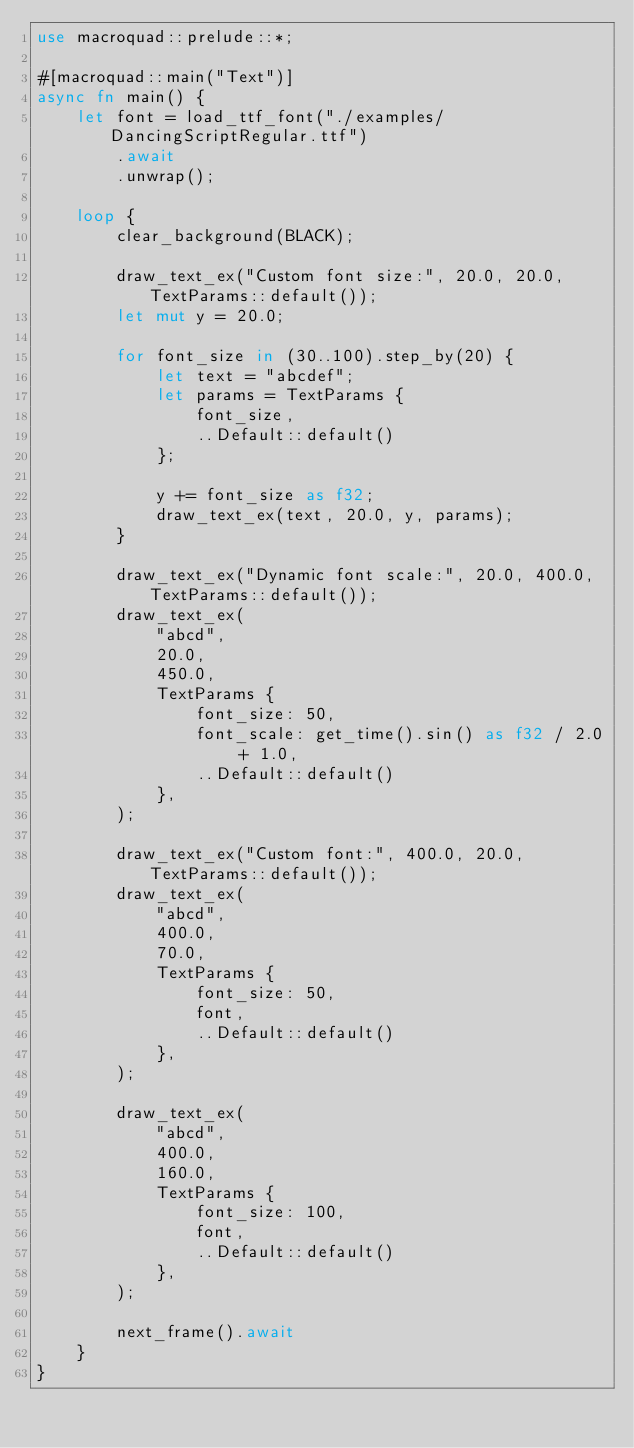<code> <loc_0><loc_0><loc_500><loc_500><_Rust_>use macroquad::prelude::*;

#[macroquad::main("Text")]
async fn main() {
    let font = load_ttf_font("./examples/DancingScriptRegular.ttf")
        .await
        .unwrap();

    loop {
        clear_background(BLACK);

        draw_text_ex("Custom font size:", 20.0, 20.0, TextParams::default());
        let mut y = 20.0;

        for font_size in (30..100).step_by(20) {
            let text = "abcdef";
            let params = TextParams {
                font_size,
                ..Default::default()
            };

            y += font_size as f32;
            draw_text_ex(text, 20.0, y, params);
        }

        draw_text_ex("Dynamic font scale:", 20.0, 400.0, TextParams::default());
        draw_text_ex(
            "abcd",
            20.0,
            450.0,
            TextParams {
                font_size: 50,
                font_scale: get_time().sin() as f32 / 2.0 + 1.0,
                ..Default::default()
            },
        );

        draw_text_ex("Custom font:", 400.0, 20.0, TextParams::default());
        draw_text_ex(
            "abcd",
            400.0,
            70.0,
            TextParams {
                font_size: 50,
                font,
                ..Default::default()
            },
        );

        draw_text_ex(
            "abcd",
            400.0,
            160.0,
            TextParams {
                font_size: 100,
                font,
                ..Default::default()
            },
        );

        next_frame().await
    }
}
</code> 